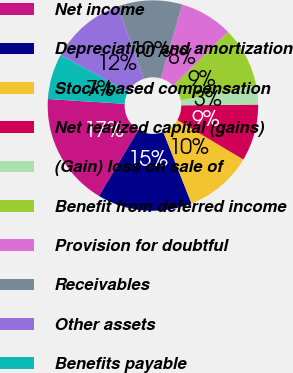Convert chart to OTSL. <chart><loc_0><loc_0><loc_500><loc_500><pie_chart><fcel>Net income<fcel>Depreciation and amortization<fcel>Stock-based compensation<fcel>Net realized capital (gains)<fcel>(Gain) loss on sale of<fcel>Benefit from deferred income<fcel>Provision for doubtful<fcel>Receivables<fcel>Other assets<fcel>Benefits payable<nl><fcel>17.44%<fcel>14.53%<fcel>10.47%<fcel>8.72%<fcel>2.91%<fcel>9.3%<fcel>8.14%<fcel>9.88%<fcel>11.63%<fcel>6.98%<nl></chart> 